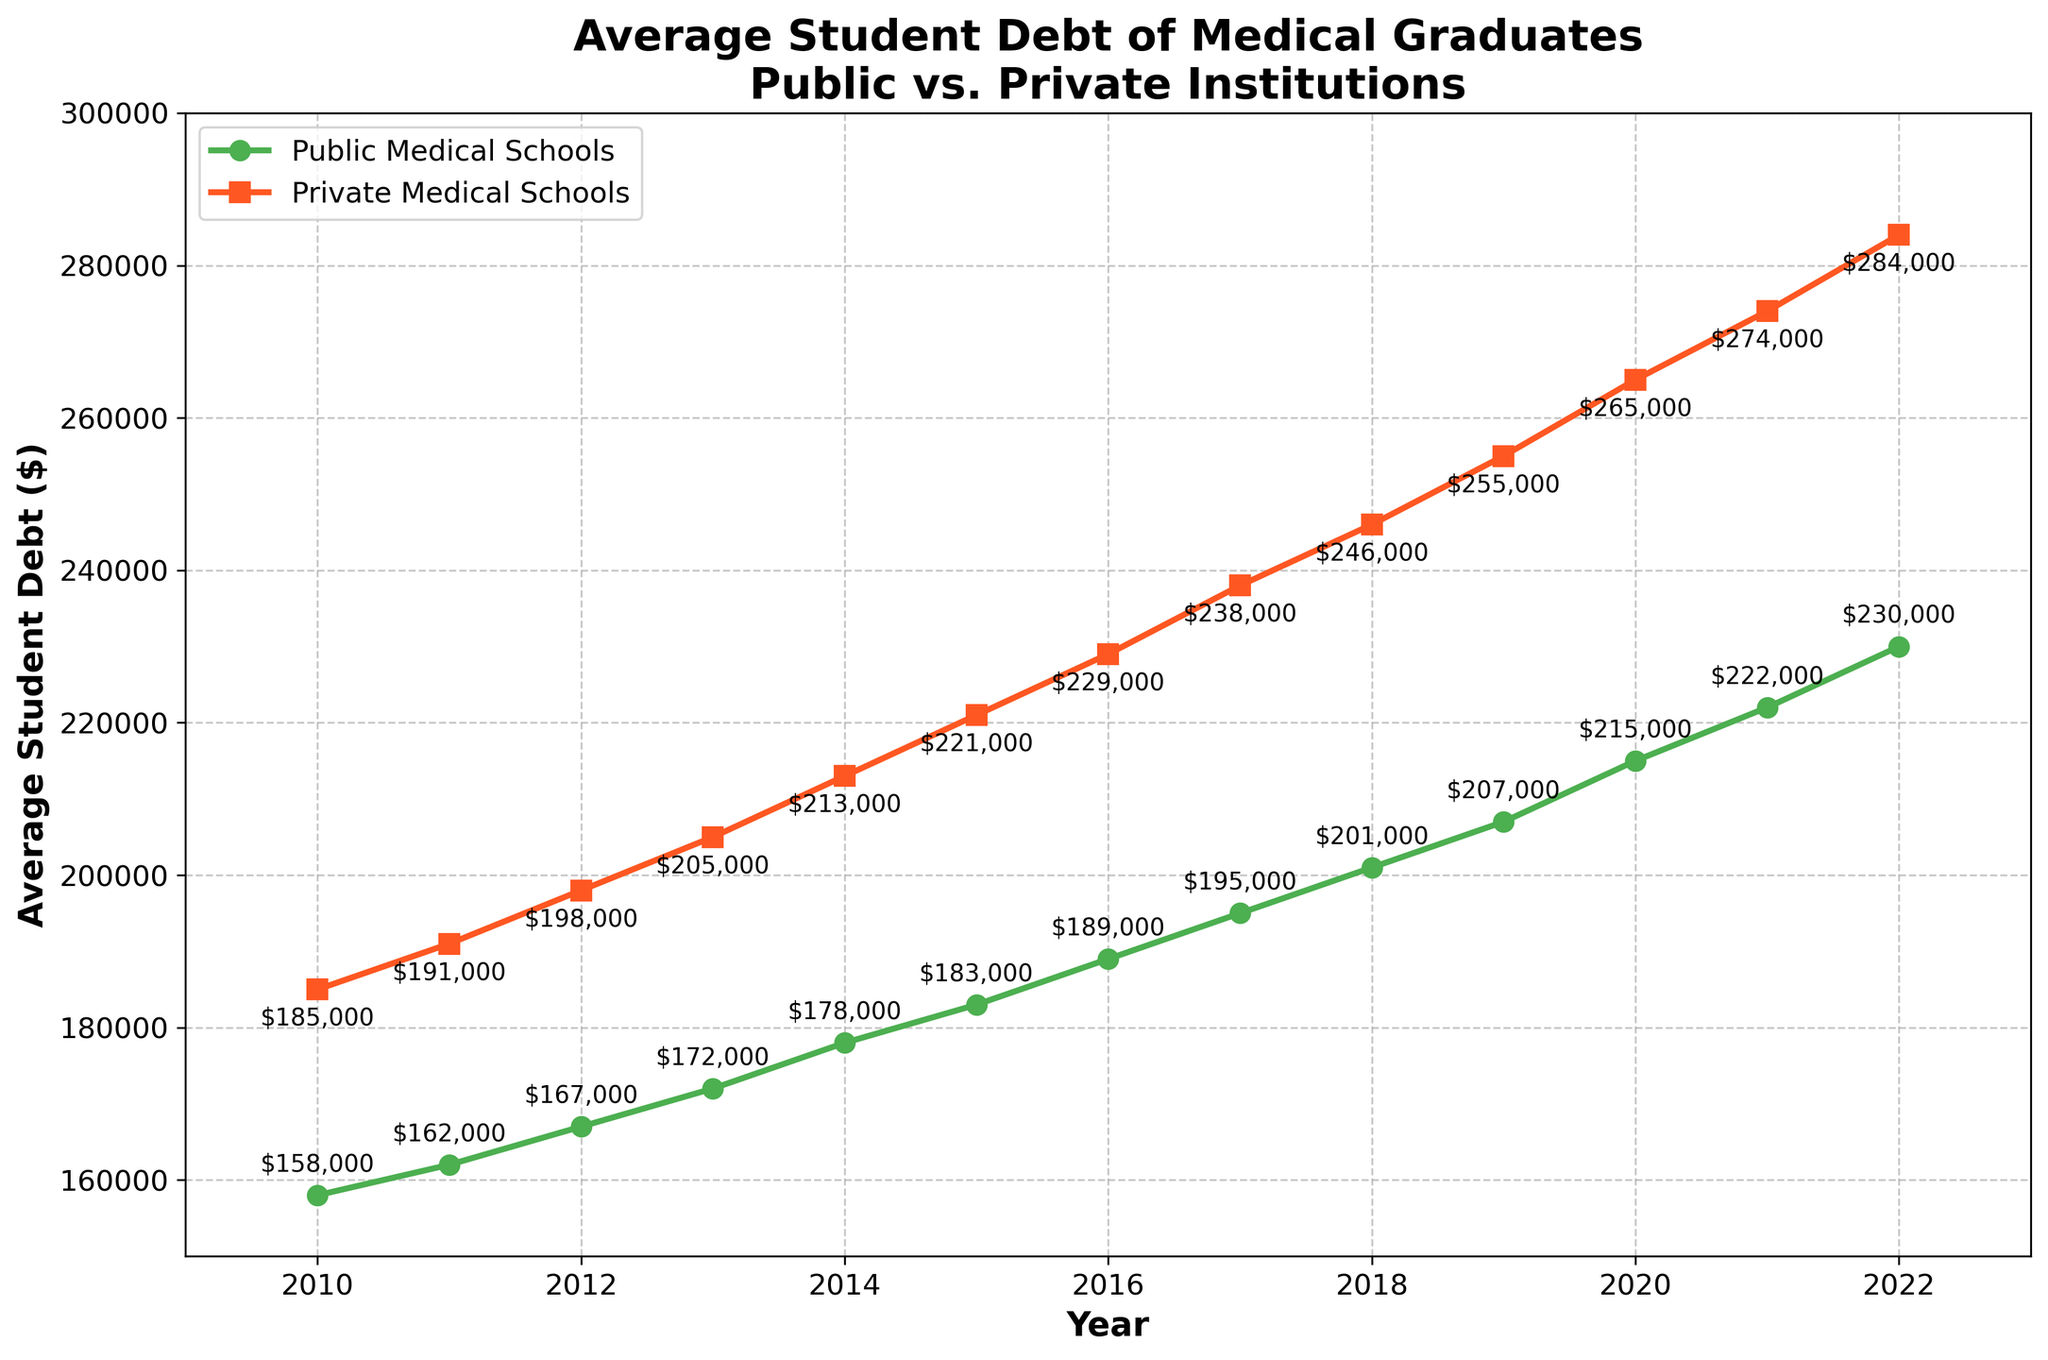Which type of institution had the higher average student debt in 2022? Compare the data points for public and private medical schools in 2022. The average student debt for private medical schools was $284,000, whereas for public medical schools, it was $230,000.
Answer: Private medical schools What was the average student debt for public medical schools in 2015? Refer to the 2015 data point for public medical schools. The average student debt for students from public medical schools in 2015 was $183,000.
Answer: $183,000 By how much did the average student debt for private medical schools increase from 2010 to 2022? Subtract the average student debt in 2010 from the average student debt in 2022 for private medical schools: $284,000 - $185,000. This results in an increase of $99,000.
Answer: $99,000 What is the trend line like for the average student debt in both public and private medical schools over the years? Both trend lines for public and private medical schools show an upward trajectory, indicating a consistent increase in average student debt each year from 2010 to 2022.
Answer: Upward How does the difference in student debt between public and private medical school graduates change from 2010 to 2019? For 2010, the difference was $185,000 - $158,000 = $27,000 and for 2019, it was $255,000 - $207,000 = $48,000. This shows the difference increased by $21,000 over these years.
Answer: Increased by $21,000 Which year shows the highest increase in average student debt for public medical schools? Analyze the changes in average student debt year by year and identify the year with the largest increase. From 2019 to 2020, the increase was $215,000 - $207,000 = $8,000, which is the highest.
Answer: 2019 to 2020 What is the slope of the line for private medical schools between 2018 and 2019? Calculate the change in student debt between these two years: $255,000 - $246,000 = $9,000. Since the period is one year, the slope (rate of increase per year) is $9,000 per year.
Answer: $9,000 per year Are there any years where the average student debt for public medical schools equals or exceeds $200,000? Look through the data for the years where the public medical schools' average debt is $200,000 or more. This first occurs in 2020 with $215,000, and successive years also show values higher than $200,000.
Answer: Yes, 2020 onwards 